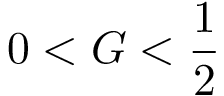<formula> <loc_0><loc_0><loc_500><loc_500>0 < G < \frac { 1 } { 2 }</formula> 